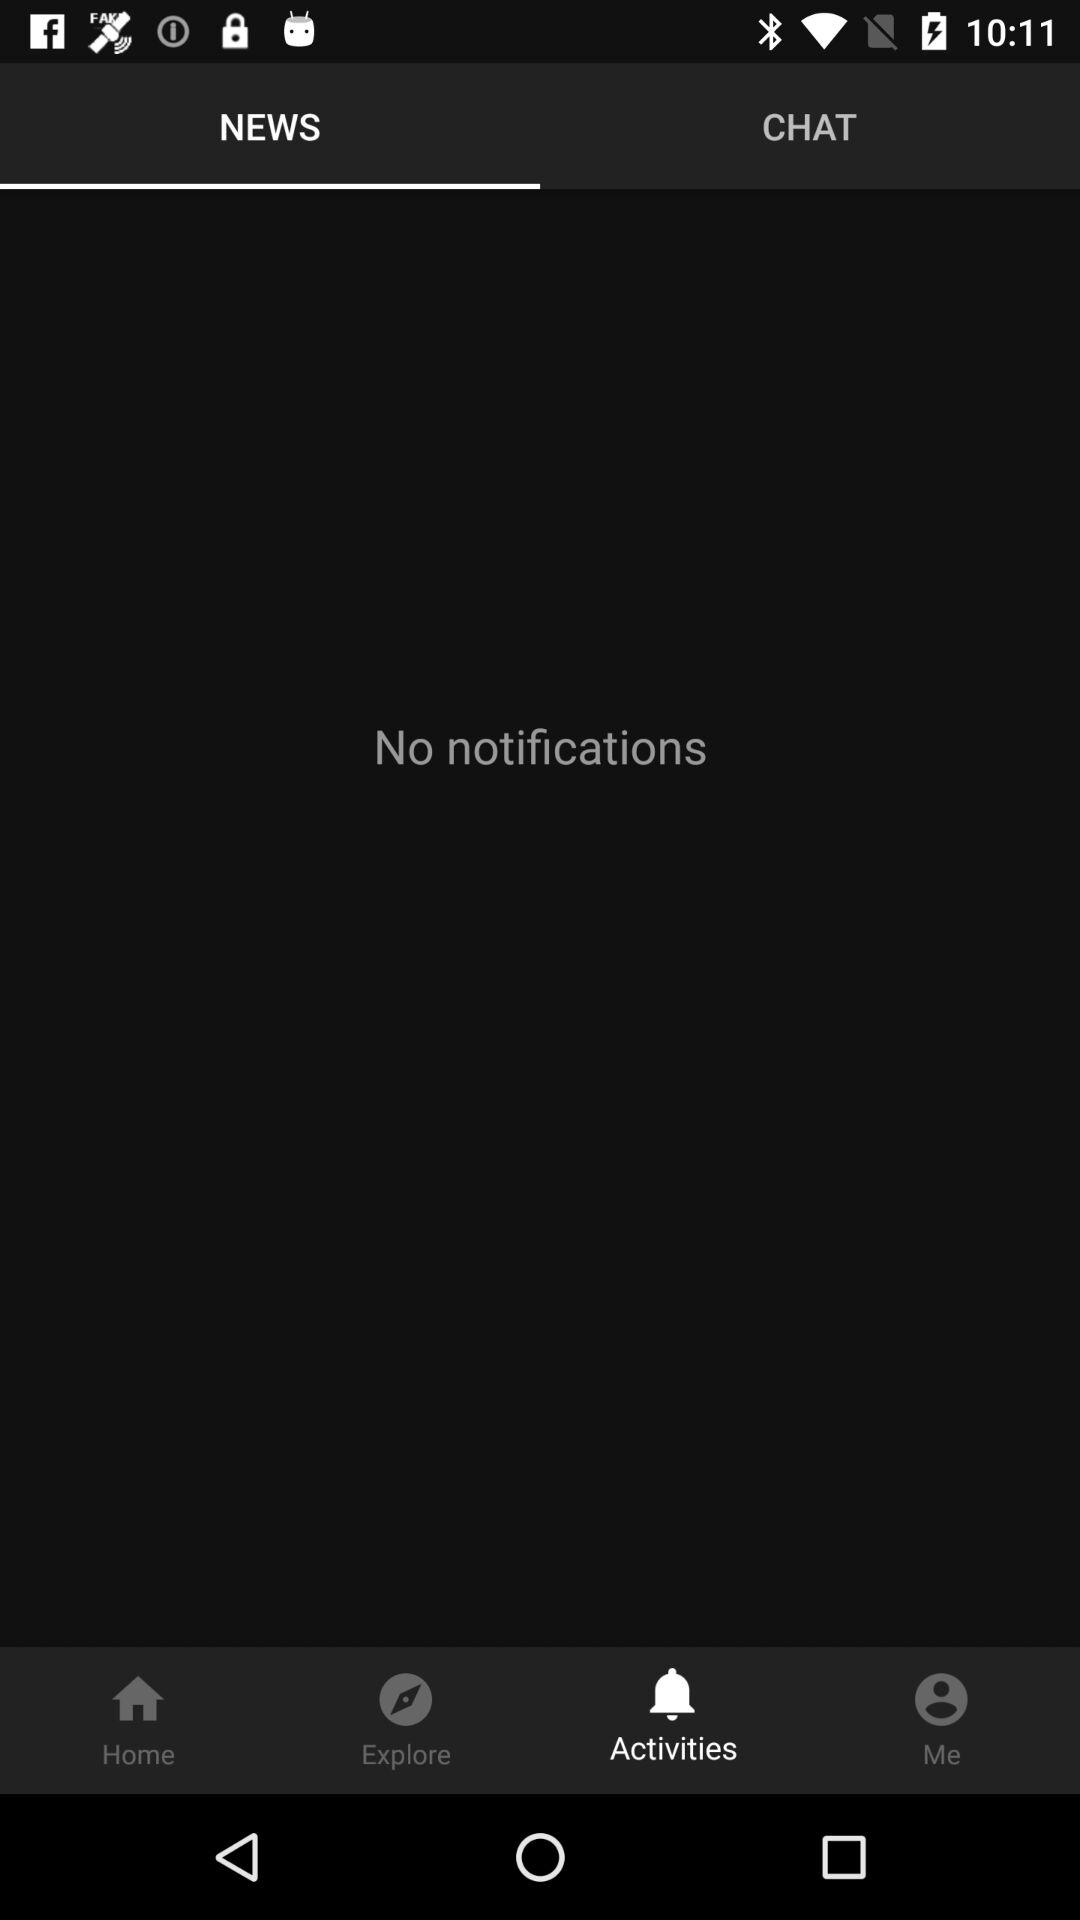How many notifications are there?
Answer the question using a single word or phrase. 0 